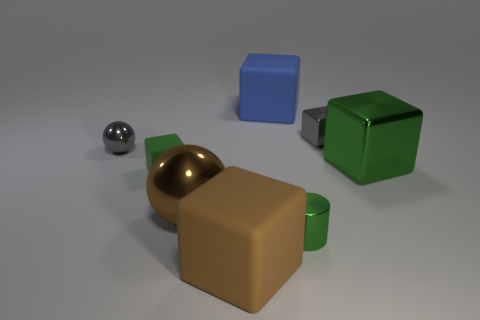Subtract all large green cubes. How many cubes are left? 4 Add 1 blue matte spheres. How many objects exist? 9 Subtract all balls. How many objects are left? 6 Subtract 3 blocks. How many blocks are left? 2 Subtract all red balls. Subtract all purple blocks. How many balls are left? 2 Subtract all red spheres. How many gray blocks are left? 1 Subtract all small gray objects. Subtract all tiny rubber blocks. How many objects are left? 5 Add 5 large blue matte blocks. How many large blue matte blocks are left? 6 Add 1 large brown blocks. How many large brown blocks exist? 2 Subtract all gray balls. How many balls are left? 1 